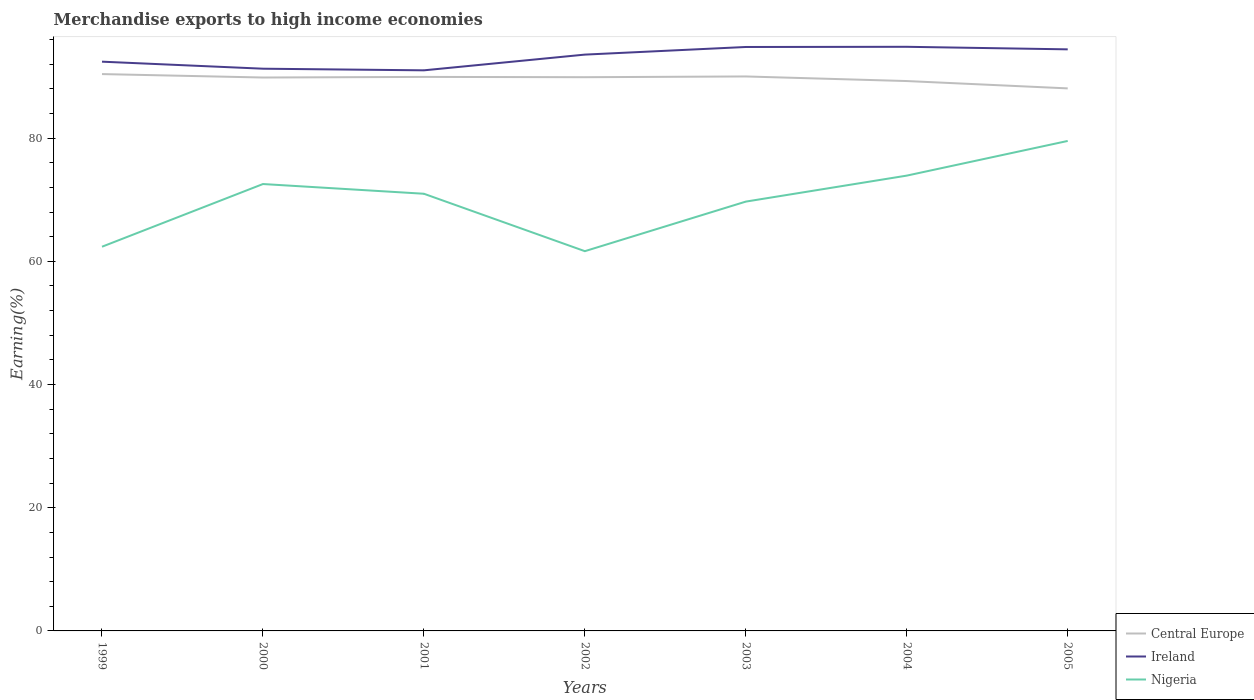How many different coloured lines are there?
Offer a terse response. 3. Across all years, what is the maximum percentage of amount earned from merchandise exports in Nigeria?
Give a very brief answer. 61.65. What is the total percentage of amount earned from merchandise exports in Ireland in the graph?
Your response must be concise. -3.56. What is the difference between the highest and the second highest percentage of amount earned from merchandise exports in Central Europe?
Your answer should be very brief. 2.32. What is the difference between the highest and the lowest percentage of amount earned from merchandise exports in Central Europe?
Keep it short and to the point. 5. What is the difference between two consecutive major ticks on the Y-axis?
Give a very brief answer. 20. Are the values on the major ticks of Y-axis written in scientific E-notation?
Your response must be concise. No. Does the graph contain any zero values?
Make the answer very short. No. Where does the legend appear in the graph?
Your response must be concise. Bottom right. What is the title of the graph?
Give a very brief answer. Merchandise exports to high income economies. Does "Tunisia" appear as one of the legend labels in the graph?
Provide a succinct answer. No. What is the label or title of the Y-axis?
Your answer should be compact. Earning(%). What is the Earning(%) in Central Europe in 1999?
Offer a very short reply. 90.41. What is the Earning(%) of Ireland in 1999?
Keep it short and to the point. 92.42. What is the Earning(%) of Nigeria in 1999?
Offer a terse response. 62.38. What is the Earning(%) of Central Europe in 2000?
Provide a succinct answer. 89.85. What is the Earning(%) of Ireland in 2000?
Your answer should be very brief. 91.28. What is the Earning(%) in Nigeria in 2000?
Keep it short and to the point. 72.55. What is the Earning(%) of Central Europe in 2001?
Provide a succinct answer. 89.95. What is the Earning(%) in Ireland in 2001?
Offer a very short reply. 91.01. What is the Earning(%) of Nigeria in 2001?
Make the answer very short. 70.98. What is the Earning(%) in Central Europe in 2002?
Your answer should be very brief. 89.9. What is the Earning(%) in Ireland in 2002?
Give a very brief answer. 93.57. What is the Earning(%) in Nigeria in 2002?
Offer a very short reply. 61.65. What is the Earning(%) of Central Europe in 2003?
Keep it short and to the point. 90.02. What is the Earning(%) in Ireland in 2003?
Keep it short and to the point. 94.81. What is the Earning(%) of Nigeria in 2003?
Offer a terse response. 69.7. What is the Earning(%) of Central Europe in 2004?
Offer a very short reply. 89.27. What is the Earning(%) in Ireland in 2004?
Make the answer very short. 94.84. What is the Earning(%) of Nigeria in 2004?
Ensure brevity in your answer.  73.92. What is the Earning(%) in Central Europe in 2005?
Offer a terse response. 88.08. What is the Earning(%) in Ireland in 2005?
Make the answer very short. 94.42. What is the Earning(%) of Nigeria in 2005?
Offer a terse response. 79.55. Across all years, what is the maximum Earning(%) in Central Europe?
Provide a succinct answer. 90.41. Across all years, what is the maximum Earning(%) in Ireland?
Offer a very short reply. 94.84. Across all years, what is the maximum Earning(%) in Nigeria?
Offer a very short reply. 79.55. Across all years, what is the minimum Earning(%) in Central Europe?
Your answer should be compact. 88.08. Across all years, what is the minimum Earning(%) in Ireland?
Make the answer very short. 91.01. Across all years, what is the minimum Earning(%) of Nigeria?
Provide a succinct answer. 61.65. What is the total Earning(%) in Central Europe in the graph?
Offer a terse response. 627.48. What is the total Earning(%) of Ireland in the graph?
Offer a very short reply. 652.35. What is the total Earning(%) of Nigeria in the graph?
Offer a very short reply. 490.73. What is the difference between the Earning(%) of Central Europe in 1999 and that in 2000?
Your answer should be very brief. 0.56. What is the difference between the Earning(%) of Ireland in 1999 and that in 2000?
Offer a very short reply. 1.14. What is the difference between the Earning(%) in Nigeria in 1999 and that in 2000?
Ensure brevity in your answer.  -10.18. What is the difference between the Earning(%) in Central Europe in 1999 and that in 2001?
Your answer should be compact. 0.46. What is the difference between the Earning(%) in Ireland in 1999 and that in 2001?
Your answer should be very brief. 1.41. What is the difference between the Earning(%) in Nigeria in 1999 and that in 2001?
Keep it short and to the point. -8.6. What is the difference between the Earning(%) of Central Europe in 1999 and that in 2002?
Offer a terse response. 0.51. What is the difference between the Earning(%) of Ireland in 1999 and that in 2002?
Your answer should be very brief. -1.15. What is the difference between the Earning(%) of Nigeria in 1999 and that in 2002?
Ensure brevity in your answer.  0.72. What is the difference between the Earning(%) in Central Europe in 1999 and that in 2003?
Provide a succinct answer. 0.39. What is the difference between the Earning(%) in Ireland in 1999 and that in 2003?
Ensure brevity in your answer.  -2.39. What is the difference between the Earning(%) of Nigeria in 1999 and that in 2003?
Keep it short and to the point. -7.33. What is the difference between the Earning(%) of Central Europe in 1999 and that in 2004?
Provide a succinct answer. 1.13. What is the difference between the Earning(%) in Ireland in 1999 and that in 2004?
Provide a short and direct response. -2.42. What is the difference between the Earning(%) of Nigeria in 1999 and that in 2004?
Your answer should be very brief. -11.55. What is the difference between the Earning(%) in Central Europe in 1999 and that in 2005?
Your answer should be compact. 2.32. What is the difference between the Earning(%) of Ireland in 1999 and that in 2005?
Offer a terse response. -2. What is the difference between the Earning(%) in Nigeria in 1999 and that in 2005?
Provide a succinct answer. -17.18. What is the difference between the Earning(%) in Central Europe in 2000 and that in 2001?
Provide a succinct answer. -0.1. What is the difference between the Earning(%) in Ireland in 2000 and that in 2001?
Your response must be concise. 0.27. What is the difference between the Earning(%) in Nigeria in 2000 and that in 2001?
Your answer should be compact. 1.58. What is the difference between the Earning(%) of Central Europe in 2000 and that in 2002?
Keep it short and to the point. -0.05. What is the difference between the Earning(%) of Ireland in 2000 and that in 2002?
Your answer should be compact. -2.29. What is the difference between the Earning(%) of Nigeria in 2000 and that in 2002?
Make the answer very short. 10.9. What is the difference between the Earning(%) of Central Europe in 2000 and that in 2003?
Offer a very short reply. -0.17. What is the difference between the Earning(%) of Ireland in 2000 and that in 2003?
Give a very brief answer. -3.53. What is the difference between the Earning(%) of Nigeria in 2000 and that in 2003?
Your answer should be very brief. 2.85. What is the difference between the Earning(%) of Central Europe in 2000 and that in 2004?
Offer a terse response. 0.57. What is the difference between the Earning(%) in Ireland in 2000 and that in 2004?
Offer a terse response. -3.56. What is the difference between the Earning(%) in Nigeria in 2000 and that in 2004?
Your response must be concise. -1.37. What is the difference between the Earning(%) of Central Europe in 2000 and that in 2005?
Your response must be concise. 1.77. What is the difference between the Earning(%) in Ireland in 2000 and that in 2005?
Your response must be concise. -3.14. What is the difference between the Earning(%) of Nigeria in 2000 and that in 2005?
Ensure brevity in your answer.  -7. What is the difference between the Earning(%) of Central Europe in 2001 and that in 2002?
Make the answer very short. 0.05. What is the difference between the Earning(%) of Ireland in 2001 and that in 2002?
Your answer should be compact. -2.55. What is the difference between the Earning(%) in Nigeria in 2001 and that in 2002?
Ensure brevity in your answer.  9.32. What is the difference between the Earning(%) in Central Europe in 2001 and that in 2003?
Give a very brief answer. -0.07. What is the difference between the Earning(%) in Ireland in 2001 and that in 2003?
Offer a very short reply. -3.79. What is the difference between the Earning(%) of Nigeria in 2001 and that in 2003?
Offer a very short reply. 1.28. What is the difference between the Earning(%) of Central Europe in 2001 and that in 2004?
Offer a terse response. 0.67. What is the difference between the Earning(%) of Ireland in 2001 and that in 2004?
Give a very brief answer. -3.82. What is the difference between the Earning(%) of Nigeria in 2001 and that in 2004?
Offer a very short reply. -2.94. What is the difference between the Earning(%) of Central Europe in 2001 and that in 2005?
Offer a very short reply. 1.87. What is the difference between the Earning(%) of Ireland in 2001 and that in 2005?
Give a very brief answer. -3.41. What is the difference between the Earning(%) of Nigeria in 2001 and that in 2005?
Provide a succinct answer. -8.57. What is the difference between the Earning(%) of Central Europe in 2002 and that in 2003?
Give a very brief answer. -0.12. What is the difference between the Earning(%) in Ireland in 2002 and that in 2003?
Offer a terse response. -1.24. What is the difference between the Earning(%) of Nigeria in 2002 and that in 2003?
Offer a very short reply. -8.05. What is the difference between the Earning(%) in Central Europe in 2002 and that in 2004?
Keep it short and to the point. 0.62. What is the difference between the Earning(%) of Ireland in 2002 and that in 2004?
Offer a terse response. -1.27. What is the difference between the Earning(%) in Nigeria in 2002 and that in 2004?
Ensure brevity in your answer.  -12.27. What is the difference between the Earning(%) of Central Europe in 2002 and that in 2005?
Ensure brevity in your answer.  1.82. What is the difference between the Earning(%) in Ireland in 2002 and that in 2005?
Make the answer very short. -0.85. What is the difference between the Earning(%) of Nigeria in 2002 and that in 2005?
Ensure brevity in your answer.  -17.9. What is the difference between the Earning(%) of Central Europe in 2003 and that in 2004?
Keep it short and to the point. 0.75. What is the difference between the Earning(%) in Ireland in 2003 and that in 2004?
Provide a short and direct response. -0.03. What is the difference between the Earning(%) in Nigeria in 2003 and that in 2004?
Make the answer very short. -4.22. What is the difference between the Earning(%) of Central Europe in 2003 and that in 2005?
Give a very brief answer. 1.94. What is the difference between the Earning(%) in Ireland in 2003 and that in 2005?
Provide a succinct answer. 0.39. What is the difference between the Earning(%) of Nigeria in 2003 and that in 2005?
Ensure brevity in your answer.  -9.85. What is the difference between the Earning(%) in Central Europe in 2004 and that in 2005?
Keep it short and to the point. 1.19. What is the difference between the Earning(%) of Ireland in 2004 and that in 2005?
Make the answer very short. 0.42. What is the difference between the Earning(%) of Nigeria in 2004 and that in 2005?
Offer a terse response. -5.63. What is the difference between the Earning(%) in Central Europe in 1999 and the Earning(%) in Ireland in 2000?
Provide a succinct answer. -0.87. What is the difference between the Earning(%) in Central Europe in 1999 and the Earning(%) in Nigeria in 2000?
Ensure brevity in your answer.  17.85. What is the difference between the Earning(%) of Ireland in 1999 and the Earning(%) of Nigeria in 2000?
Keep it short and to the point. 19.87. What is the difference between the Earning(%) of Central Europe in 1999 and the Earning(%) of Ireland in 2001?
Provide a short and direct response. -0.61. What is the difference between the Earning(%) of Central Europe in 1999 and the Earning(%) of Nigeria in 2001?
Provide a short and direct response. 19.43. What is the difference between the Earning(%) of Ireland in 1999 and the Earning(%) of Nigeria in 2001?
Offer a very short reply. 21.44. What is the difference between the Earning(%) in Central Europe in 1999 and the Earning(%) in Ireland in 2002?
Give a very brief answer. -3.16. What is the difference between the Earning(%) in Central Europe in 1999 and the Earning(%) in Nigeria in 2002?
Keep it short and to the point. 28.75. What is the difference between the Earning(%) in Ireland in 1999 and the Earning(%) in Nigeria in 2002?
Offer a very short reply. 30.77. What is the difference between the Earning(%) in Central Europe in 1999 and the Earning(%) in Ireland in 2003?
Provide a short and direct response. -4.4. What is the difference between the Earning(%) of Central Europe in 1999 and the Earning(%) of Nigeria in 2003?
Ensure brevity in your answer.  20.7. What is the difference between the Earning(%) of Ireland in 1999 and the Earning(%) of Nigeria in 2003?
Offer a very short reply. 22.72. What is the difference between the Earning(%) in Central Europe in 1999 and the Earning(%) in Ireland in 2004?
Your response must be concise. -4.43. What is the difference between the Earning(%) in Central Europe in 1999 and the Earning(%) in Nigeria in 2004?
Your answer should be compact. 16.49. What is the difference between the Earning(%) of Ireland in 1999 and the Earning(%) of Nigeria in 2004?
Your response must be concise. 18.5. What is the difference between the Earning(%) of Central Europe in 1999 and the Earning(%) of Ireland in 2005?
Keep it short and to the point. -4.01. What is the difference between the Earning(%) of Central Europe in 1999 and the Earning(%) of Nigeria in 2005?
Provide a short and direct response. 10.86. What is the difference between the Earning(%) in Ireland in 1999 and the Earning(%) in Nigeria in 2005?
Provide a short and direct response. 12.87. What is the difference between the Earning(%) in Central Europe in 2000 and the Earning(%) in Ireland in 2001?
Keep it short and to the point. -1.17. What is the difference between the Earning(%) of Central Europe in 2000 and the Earning(%) of Nigeria in 2001?
Offer a terse response. 18.87. What is the difference between the Earning(%) in Ireland in 2000 and the Earning(%) in Nigeria in 2001?
Your response must be concise. 20.3. What is the difference between the Earning(%) in Central Europe in 2000 and the Earning(%) in Ireland in 2002?
Provide a succinct answer. -3.72. What is the difference between the Earning(%) in Central Europe in 2000 and the Earning(%) in Nigeria in 2002?
Your answer should be very brief. 28.19. What is the difference between the Earning(%) of Ireland in 2000 and the Earning(%) of Nigeria in 2002?
Keep it short and to the point. 29.63. What is the difference between the Earning(%) of Central Europe in 2000 and the Earning(%) of Ireland in 2003?
Provide a succinct answer. -4.96. What is the difference between the Earning(%) in Central Europe in 2000 and the Earning(%) in Nigeria in 2003?
Offer a terse response. 20.15. What is the difference between the Earning(%) of Ireland in 2000 and the Earning(%) of Nigeria in 2003?
Provide a short and direct response. 21.58. What is the difference between the Earning(%) of Central Europe in 2000 and the Earning(%) of Ireland in 2004?
Offer a very short reply. -4.99. What is the difference between the Earning(%) in Central Europe in 2000 and the Earning(%) in Nigeria in 2004?
Give a very brief answer. 15.93. What is the difference between the Earning(%) in Ireland in 2000 and the Earning(%) in Nigeria in 2004?
Provide a short and direct response. 17.36. What is the difference between the Earning(%) of Central Europe in 2000 and the Earning(%) of Ireland in 2005?
Keep it short and to the point. -4.57. What is the difference between the Earning(%) in Central Europe in 2000 and the Earning(%) in Nigeria in 2005?
Keep it short and to the point. 10.3. What is the difference between the Earning(%) in Ireland in 2000 and the Earning(%) in Nigeria in 2005?
Your answer should be very brief. 11.73. What is the difference between the Earning(%) in Central Europe in 2001 and the Earning(%) in Ireland in 2002?
Offer a terse response. -3.62. What is the difference between the Earning(%) of Central Europe in 2001 and the Earning(%) of Nigeria in 2002?
Your response must be concise. 28.29. What is the difference between the Earning(%) of Ireland in 2001 and the Earning(%) of Nigeria in 2002?
Make the answer very short. 29.36. What is the difference between the Earning(%) in Central Europe in 2001 and the Earning(%) in Ireland in 2003?
Offer a very short reply. -4.86. What is the difference between the Earning(%) in Central Europe in 2001 and the Earning(%) in Nigeria in 2003?
Make the answer very short. 20.25. What is the difference between the Earning(%) of Ireland in 2001 and the Earning(%) of Nigeria in 2003?
Offer a terse response. 21.31. What is the difference between the Earning(%) in Central Europe in 2001 and the Earning(%) in Ireland in 2004?
Offer a terse response. -4.89. What is the difference between the Earning(%) in Central Europe in 2001 and the Earning(%) in Nigeria in 2004?
Your answer should be very brief. 16.03. What is the difference between the Earning(%) of Ireland in 2001 and the Earning(%) of Nigeria in 2004?
Offer a very short reply. 17.09. What is the difference between the Earning(%) of Central Europe in 2001 and the Earning(%) of Ireland in 2005?
Make the answer very short. -4.47. What is the difference between the Earning(%) of Central Europe in 2001 and the Earning(%) of Nigeria in 2005?
Provide a succinct answer. 10.4. What is the difference between the Earning(%) of Ireland in 2001 and the Earning(%) of Nigeria in 2005?
Provide a short and direct response. 11.46. What is the difference between the Earning(%) in Central Europe in 2002 and the Earning(%) in Ireland in 2003?
Offer a terse response. -4.91. What is the difference between the Earning(%) in Central Europe in 2002 and the Earning(%) in Nigeria in 2003?
Your answer should be very brief. 20.2. What is the difference between the Earning(%) of Ireland in 2002 and the Earning(%) of Nigeria in 2003?
Ensure brevity in your answer.  23.87. What is the difference between the Earning(%) of Central Europe in 2002 and the Earning(%) of Ireland in 2004?
Offer a very short reply. -4.94. What is the difference between the Earning(%) in Central Europe in 2002 and the Earning(%) in Nigeria in 2004?
Your answer should be compact. 15.98. What is the difference between the Earning(%) of Ireland in 2002 and the Earning(%) of Nigeria in 2004?
Your answer should be very brief. 19.65. What is the difference between the Earning(%) in Central Europe in 2002 and the Earning(%) in Ireland in 2005?
Make the answer very short. -4.52. What is the difference between the Earning(%) of Central Europe in 2002 and the Earning(%) of Nigeria in 2005?
Provide a short and direct response. 10.35. What is the difference between the Earning(%) in Ireland in 2002 and the Earning(%) in Nigeria in 2005?
Offer a very short reply. 14.02. What is the difference between the Earning(%) of Central Europe in 2003 and the Earning(%) of Ireland in 2004?
Offer a terse response. -4.82. What is the difference between the Earning(%) in Central Europe in 2003 and the Earning(%) in Nigeria in 2004?
Offer a very short reply. 16.1. What is the difference between the Earning(%) in Ireland in 2003 and the Earning(%) in Nigeria in 2004?
Give a very brief answer. 20.89. What is the difference between the Earning(%) of Central Europe in 2003 and the Earning(%) of Ireland in 2005?
Offer a terse response. -4.4. What is the difference between the Earning(%) of Central Europe in 2003 and the Earning(%) of Nigeria in 2005?
Offer a very short reply. 10.47. What is the difference between the Earning(%) in Ireland in 2003 and the Earning(%) in Nigeria in 2005?
Your answer should be compact. 15.26. What is the difference between the Earning(%) of Central Europe in 2004 and the Earning(%) of Ireland in 2005?
Offer a very short reply. -5.15. What is the difference between the Earning(%) in Central Europe in 2004 and the Earning(%) in Nigeria in 2005?
Offer a very short reply. 9.72. What is the difference between the Earning(%) in Ireland in 2004 and the Earning(%) in Nigeria in 2005?
Your answer should be compact. 15.29. What is the average Earning(%) in Central Europe per year?
Ensure brevity in your answer.  89.64. What is the average Earning(%) of Ireland per year?
Offer a very short reply. 93.19. What is the average Earning(%) of Nigeria per year?
Offer a terse response. 70.1. In the year 1999, what is the difference between the Earning(%) of Central Europe and Earning(%) of Ireland?
Ensure brevity in your answer.  -2.01. In the year 1999, what is the difference between the Earning(%) of Central Europe and Earning(%) of Nigeria?
Ensure brevity in your answer.  28.03. In the year 1999, what is the difference between the Earning(%) of Ireland and Earning(%) of Nigeria?
Give a very brief answer. 30.05. In the year 2000, what is the difference between the Earning(%) in Central Europe and Earning(%) in Ireland?
Provide a short and direct response. -1.43. In the year 2000, what is the difference between the Earning(%) of Central Europe and Earning(%) of Nigeria?
Your answer should be very brief. 17.29. In the year 2000, what is the difference between the Earning(%) of Ireland and Earning(%) of Nigeria?
Keep it short and to the point. 18.73. In the year 2001, what is the difference between the Earning(%) in Central Europe and Earning(%) in Ireland?
Offer a very short reply. -1.07. In the year 2001, what is the difference between the Earning(%) in Central Europe and Earning(%) in Nigeria?
Your response must be concise. 18.97. In the year 2001, what is the difference between the Earning(%) of Ireland and Earning(%) of Nigeria?
Give a very brief answer. 20.04. In the year 2002, what is the difference between the Earning(%) of Central Europe and Earning(%) of Ireland?
Your answer should be very brief. -3.67. In the year 2002, what is the difference between the Earning(%) of Central Europe and Earning(%) of Nigeria?
Provide a short and direct response. 28.24. In the year 2002, what is the difference between the Earning(%) of Ireland and Earning(%) of Nigeria?
Ensure brevity in your answer.  31.91. In the year 2003, what is the difference between the Earning(%) in Central Europe and Earning(%) in Ireland?
Your answer should be compact. -4.79. In the year 2003, what is the difference between the Earning(%) of Central Europe and Earning(%) of Nigeria?
Make the answer very short. 20.32. In the year 2003, what is the difference between the Earning(%) of Ireland and Earning(%) of Nigeria?
Your answer should be very brief. 25.1. In the year 2004, what is the difference between the Earning(%) in Central Europe and Earning(%) in Ireland?
Ensure brevity in your answer.  -5.56. In the year 2004, what is the difference between the Earning(%) of Central Europe and Earning(%) of Nigeria?
Provide a short and direct response. 15.35. In the year 2004, what is the difference between the Earning(%) of Ireland and Earning(%) of Nigeria?
Make the answer very short. 20.92. In the year 2005, what is the difference between the Earning(%) of Central Europe and Earning(%) of Ireland?
Your answer should be compact. -6.34. In the year 2005, what is the difference between the Earning(%) of Central Europe and Earning(%) of Nigeria?
Offer a very short reply. 8.53. In the year 2005, what is the difference between the Earning(%) of Ireland and Earning(%) of Nigeria?
Offer a very short reply. 14.87. What is the ratio of the Earning(%) of Central Europe in 1999 to that in 2000?
Your response must be concise. 1.01. What is the ratio of the Earning(%) of Ireland in 1999 to that in 2000?
Make the answer very short. 1.01. What is the ratio of the Earning(%) in Nigeria in 1999 to that in 2000?
Offer a very short reply. 0.86. What is the ratio of the Earning(%) in Central Europe in 1999 to that in 2001?
Provide a succinct answer. 1.01. What is the ratio of the Earning(%) of Ireland in 1999 to that in 2001?
Your response must be concise. 1.02. What is the ratio of the Earning(%) in Nigeria in 1999 to that in 2001?
Your response must be concise. 0.88. What is the ratio of the Earning(%) in Central Europe in 1999 to that in 2002?
Ensure brevity in your answer.  1.01. What is the ratio of the Earning(%) in Ireland in 1999 to that in 2002?
Keep it short and to the point. 0.99. What is the ratio of the Earning(%) in Nigeria in 1999 to that in 2002?
Make the answer very short. 1.01. What is the ratio of the Earning(%) in Ireland in 1999 to that in 2003?
Ensure brevity in your answer.  0.97. What is the ratio of the Earning(%) in Nigeria in 1999 to that in 2003?
Provide a short and direct response. 0.89. What is the ratio of the Earning(%) in Central Europe in 1999 to that in 2004?
Keep it short and to the point. 1.01. What is the ratio of the Earning(%) in Ireland in 1999 to that in 2004?
Give a very brief answer. 0.97. What is the ratio of the Earning(%) in Nigeria in 1999 to that in 2004?
Offer a terse response. 0.84. What is the ratio of the Earning(%) of Central Europe in 1999 to that in 2005?
Ensure brevity in your answer.  1.03. What is the ratio of the Earning(%) in Ireland in 1999 to that in 2005?
Keep it short and to the point. 0.98. What is the ratio of the Earning(%) in Nigeria in 1999 to that in 2005?
Your answer should be compact. 0.78. What is the ratio of the Earning(%) of Ireland in 2000 to that in 2001?
Your answer should be very brief. 1. What is the ratio of the Earning(%) of Nigeria in 2000 to that in 2001?
Offer a terse response. 1.02. What is the ratio of the Earning(%) in Central Europe in 2000 to that in 2002?
Offer a very short reply. 1. What is the ratio of the Earning(%) of Ireland in 2000 to that in 2002?
Provide a short and direct response. 0.98. What is the ratio of the Earning(%) of Nigeria in 2000 to that in 2002?
Your answer should be compact. 1.18. What is the ratio of the Earning(%) of Central Europe in 2000 to that in 2003?
Your response must be concise. 1. What is the ratio of the Earning(%) in Ireland in 2000 to that in 2003?
Your answer should be very brief. 0.96. What is the ratio of the Earning(%) of Nigeria in 2000 to that in 2003?
Keep it short and to the point. 1.04. What is the ratio of the Earning(%) of Central Europe in 2000 to that in 2004?
Your response must be concise. 1.01. What is the ratio of the Earning(%) of Ireland in 2000 to that in 2004?
Keep it short and to the point. 0.96. What is the ratio of the Earning(%) in Nigeria in 2000 to that in 2004?
Make the answer very short. 0.98. What is the ratio of the Earning(%) in Central Europe in 2000 to that in 2005?
Ensure brevity in your answer.  1.02. What is the ratio of the Earning(%) of Ireland in 2000 to that in 2005?
Make the answer very short. 0.97. What is the ratio of the Earning(%) of Nigeria in 2000 to that in 2005?
Keep it short and to the point. 0.91. What is the ratio of the Earning(%) in Central Europe in 2001 to that in 2002?
Keep it short and to the point. 1. What is the ratio of the Earning(%) in Ireland in 2001 to that in 2002?
Your response must be concise. 0.97. What is the ratio of the Earning(%) of Nigeria in 2001 to that in 2002?
Offer a terse response. 1.15. What is the ratio of the Earning(%) of Central Europe in 2001 to that in 2003?
Offer a very short reply. 1. What is the ratio of the Earning(%) of Ireland in 2001 to that in 2003?
Provide a succinct answer. 0.96. What is the ratio of the Earning(%) in Nigeria in 2001 to that in 2003?
Make the answer very short. 1.02. What is the ratio of the Earning(%) in Central Europe in 2001 to that in 2004?
Provide a short and direct response. 1.01. What is the ratio of the Earning(%) of Ireland in 2001 to that in 2004?
Offer a very short reply. 0.96. What is the ratio of the Earning(%) of Nigeria in 2001 to that in 2004?
Provide a succinct answer. 0.96. What is the ratio of the Earning(%) of Central Europe in 2001 to that in 2005?
Give a very brief answer. 1.02. What is the ratio of the Earning(%) in Ireland in 2001 to that in 2005?
Offer a terse response. 0.96. What is the ratio of the Earning(%) of Nigeria in 2001 to that in 2005?
Keep it short and to the point. 0.89. What is the ratio of the Earning(%) in Central Europe in 2002 to that in 2003?
Offer a terse response. 1. What is the ratio of the Earning(%) of Ireland in 2002 to that in 2003?
Give a very brief answer. 0.99. What is the ratio of the Earning(%) in Nigeria in 2002 to that in 2003?
Your answer should be very brief. 0.88. What is the ratio of the Earning(%) in Ireland in 2002 to that in 2004?
Give a very brief answer. 0.99. What is the ratio of the Earning(%) in Nigeria in 2002 to that in 2004?
Your answer should be very brief. 0.83. What is the ratio of the Earning(%) of Central Europe in 2002 to that in 2005?
Your answer should be very brief. 1.02. What is the ratio of the Earning(%) of Ireland in 2002 to that in 2005?
Offer a terse response. 0.99. What is the ratio of the Earning(%) of Nigeria in 2002 to that in 2005?
Your answer should be compact. 0.78. What is the ratio of the Earning(%) of Central Europe in 2003 to that in 2004?
Give a very brief answer. 1.01. What is the ratio of the Earning(%) of Ireland in 2003 to that in 2004?
Your response must be concise. 1. What is the ratio of the Earning(%) in Nigeria in 2003 to that in 2004?
Your answer should be compact. 0.94. What is the ratio of the Earning(%) of Ireland in 2003 to that in 2005?
Provide a short and direct response. 1. What is the ratio of the Earning(%) in Nigeria in 2003 to that in 2005?
Keep it short and to the point. 0.88. What is the ratio of the Earning(%) of Central Europe in 2004 to that in 2005?
Offer a very short reply. 1.01. What is the ratio of the Earning(%) in Ireland in 2004 to that in 2005?
Provide a short and direct response. 1. What is the ratio of the Earning(%) of Nigeria in 2004 to that in 2005?
Make the answer very short. 0.93. What is the difference between the highest and the second highest Earning(%) in Central Europe?
Provide a succinct answer. 0.39. What is the difference between the highest and the second highest Earning(%) in Ireland?
Offer a terse response. 0.03. What is the difference between the highest and the second highest Earning(%) in Nigeria?
Offer a terse response. 5.63. What is the difference between the highest and the lowest Earning(%) of Central Europe?
Your response must be concise. 2.32. What is the difference between the highest and the lowest Earning(%) in Ireland?
Keep it short and to the point. 3.82. What is the difference between the highest and the lowest Earning(%) in Nigeria?
Ensure brevity in your answer.  17.9. 